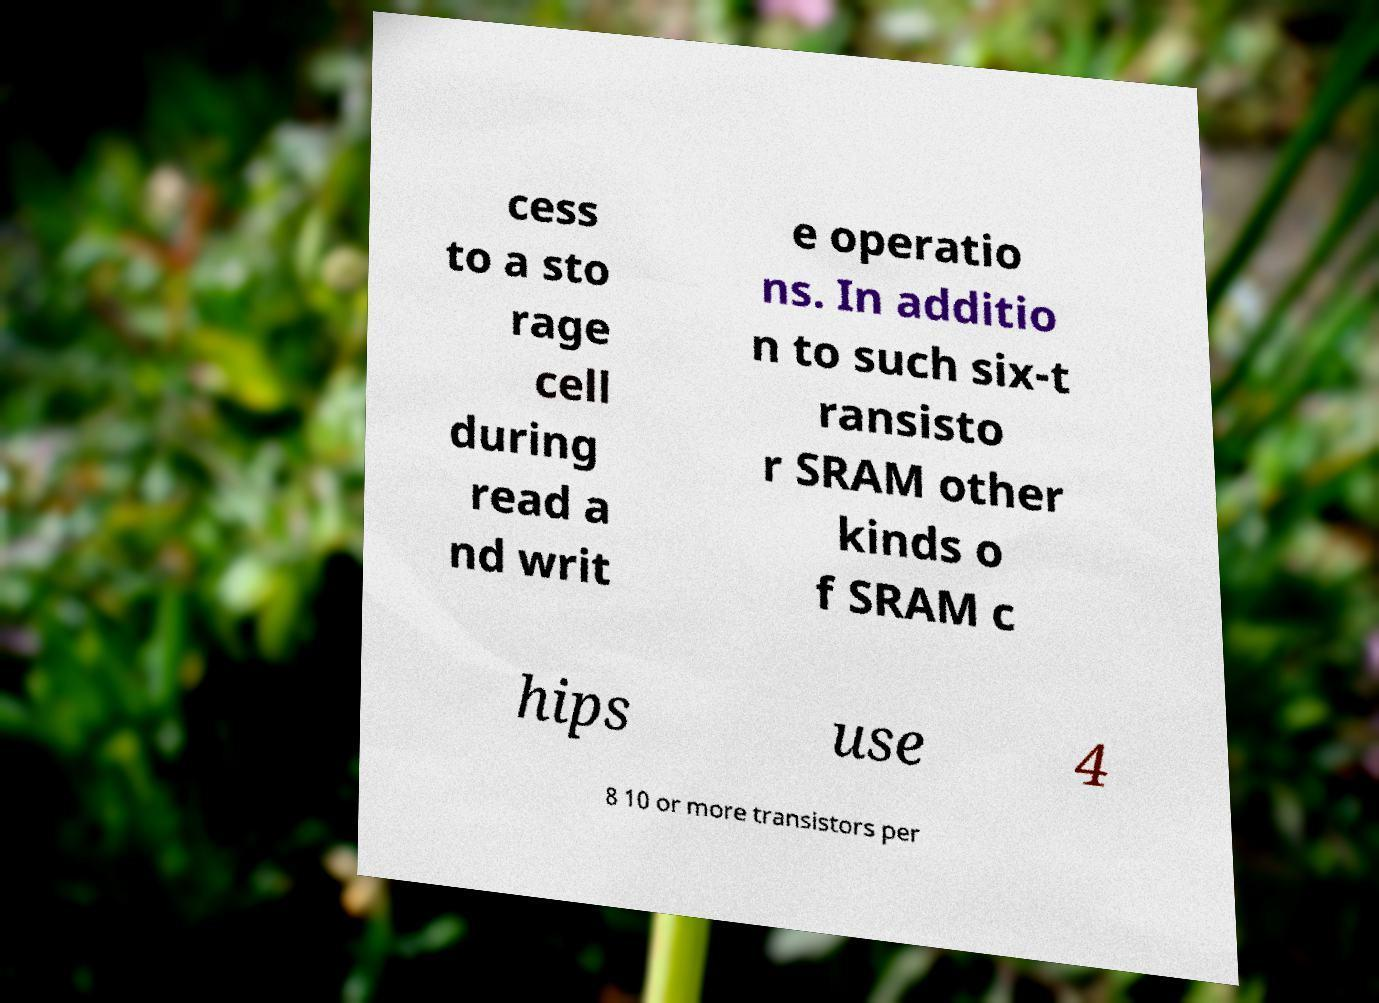Please identify and transcribe the text found in this image. cess to a sto rage cell during read a nd writ e operatio ns. In additio n to such six-t ransisto r SRAM other kinds o f SRAM c hips use 4 8 10 or more transistors per 